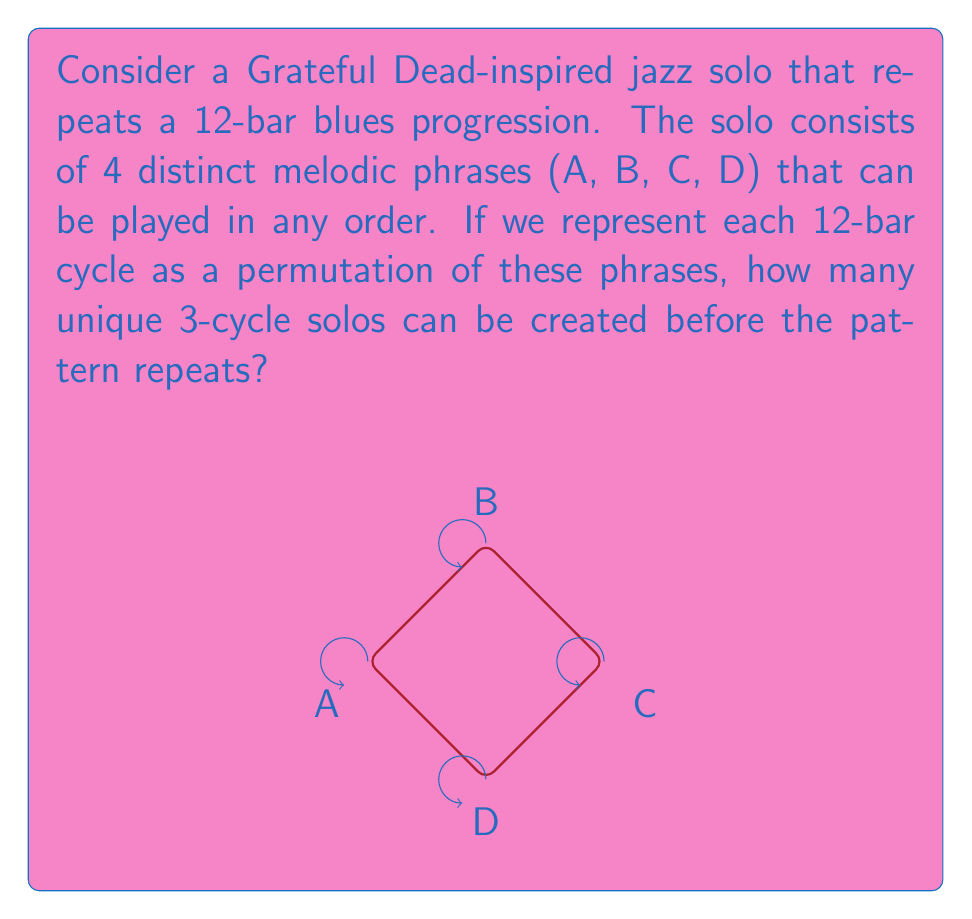Help me with this question. Let's approach this step-by-step using group theory concepts:

1) First, we need to understand what a 3-cycle solo means. It's a solo that repeats after 3 permutations of the 4 phrases.

2) In group theory, this is equivalent to finding the number of elements in the symmetric group $S_4$ with order 3.

3) The order of an element in a symmetric group is the least common multiple of the lengths of its disjoint cycles.

4) For an element to have order 3, it must be a 3-cycle (abc) or a product of disjoint 3-cycles.

5) In $S_4$, we can only have one 3-cycle, as there are only 4 elements total.

6) To count the number of 3-cycles in $S_4$:
   - We have $\binom{4}{3} = 4$ ways to choose 3 elements out of 4.
   - For each choice of 3 elements, we have 2 possible cyclic orderings.

7) Therefore, the total number of 3-cycles in $S_4$ is:

   $$4 \times 2 = 8$$

8) Each of these 3-cycles represents a unique 3-cycle solo in our jazz improvisation context.

This result aligns with the cyclic nature of jazz improvisation, where patterns often repeat but with variations, much like the music of the Grateful Dead.
Answer: 8 unique 3-cycle solos 